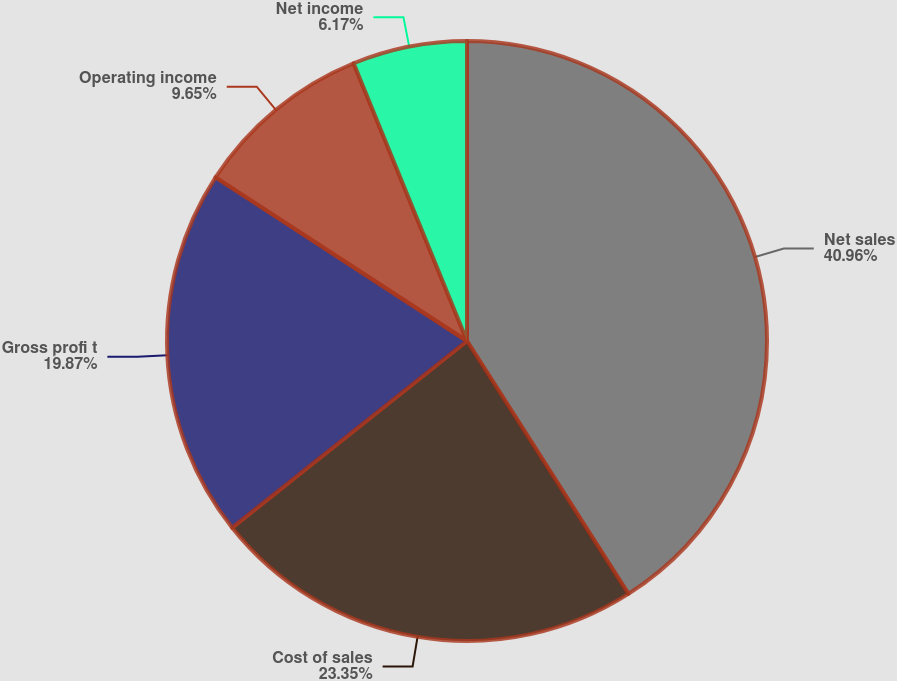<chart> <loc_0><loc_0><loc_500><loc_500><pie_chart><fcel>Net sales<fcel>Cost of sales<fcel>Gross profi t<fcel>Operating income<fcel>Net income<nl><fcel>40.96%<fcel>23.35%<fcel>19.87%<fcel>9.65%<fcel>6.17%<nl></chart> 